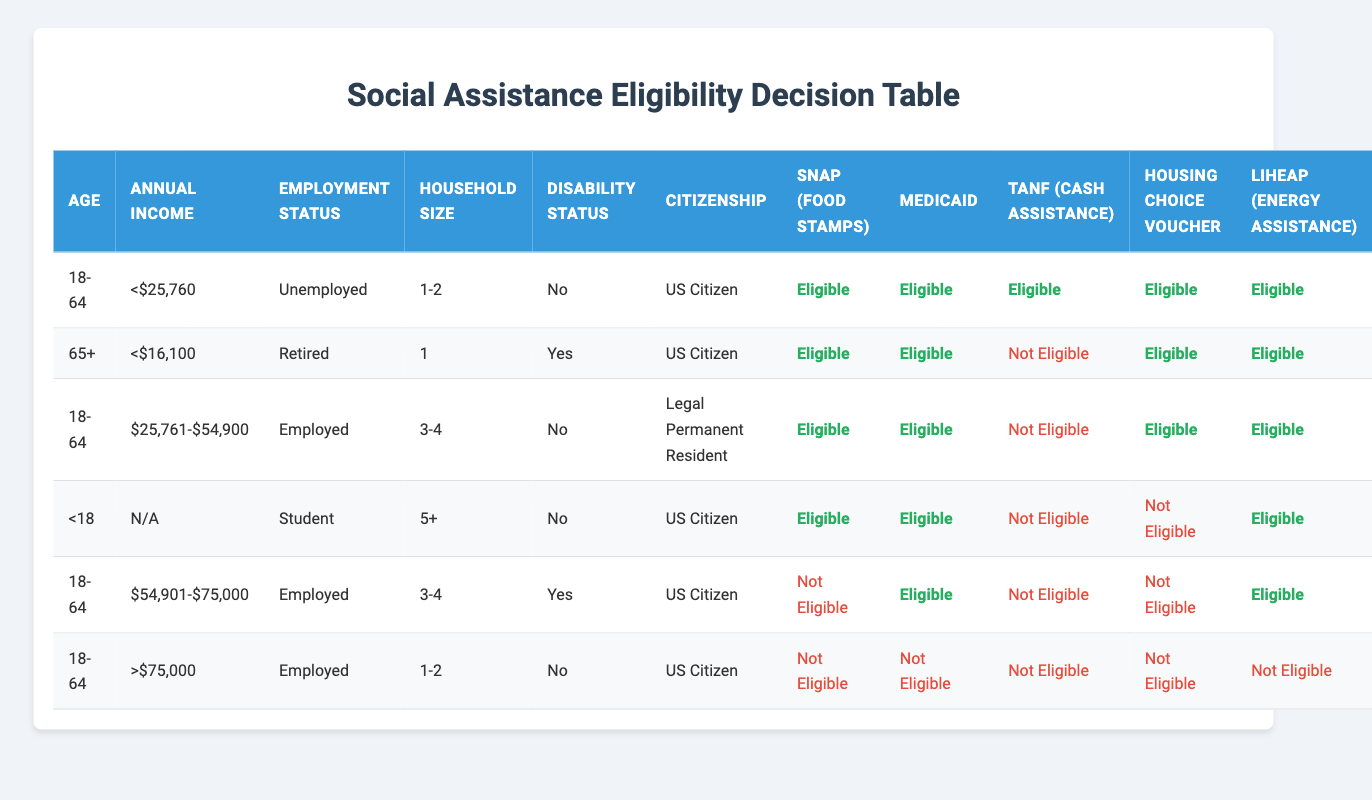What is the eligibility status for SNAP (Food Stamps) for an unemployed individual aged 18-64 with an annual income of less than $25,760? The table indicates that for the age range 18-64, if the annual income is less than $25,760 and the individual is unemployed, they are eligible for SNAP (Food Stamps) as noted in the first rule.
Answer: Eligible For individuals aged 65 and older with a disability status of "Yes," what is the eligibility status for TANF (Cash Assistance)? The eligibility status for TANF (Cash Assistance) for this age group and condition is stated in the second rule. According to that rule, individuals aged 65+ with a disability status of "Yes" are classified as not eligible for TANF.
Answer: Not Eligible How many different assistance programs is a legal permanent resident aged 18-64, employed, with an annual income of $25,761 to $54,900 eligible for? Referring to the row corresponding to legal permanent residents aged 18-64 with the specified conditions, they are eligible for SNAP, Medicaid, Housing Choice Voucher, and LIHEAP. This totals four programs.
Answer: 4 Is a student under the age of 18 who is a US citizen eligible for the Housing Choice Voucher? By checking the row for individuals under 18 who are students and US citizens, the table indicates that they are not eligible for the Housing Choice Voucher, as denoted in that specific row.
Answer: No What is the average annual income represented in the eligibility table? The annual income ranges included are: <$25,760, <$16,100, $25,761-$54,900, N/A, $54,901-$75,000, and >$75,000. To calculate an average, we focus only on the values that can be numerically evaluated: let's approximate <$25,760 as $25,000 and <$16,100 as $16,000, which gives us (25,000 + 16,000 + 40,000 + 60,000 + 75,000 + 100,000) / 6 = 52,500. The average of these approximated values, while acknowledging some variability in real values, can focus on ranges or midpoint calculations. A more intricate averaging with more detailed clarifications would yield varied outputs.
Answer: Approximately 52,500 